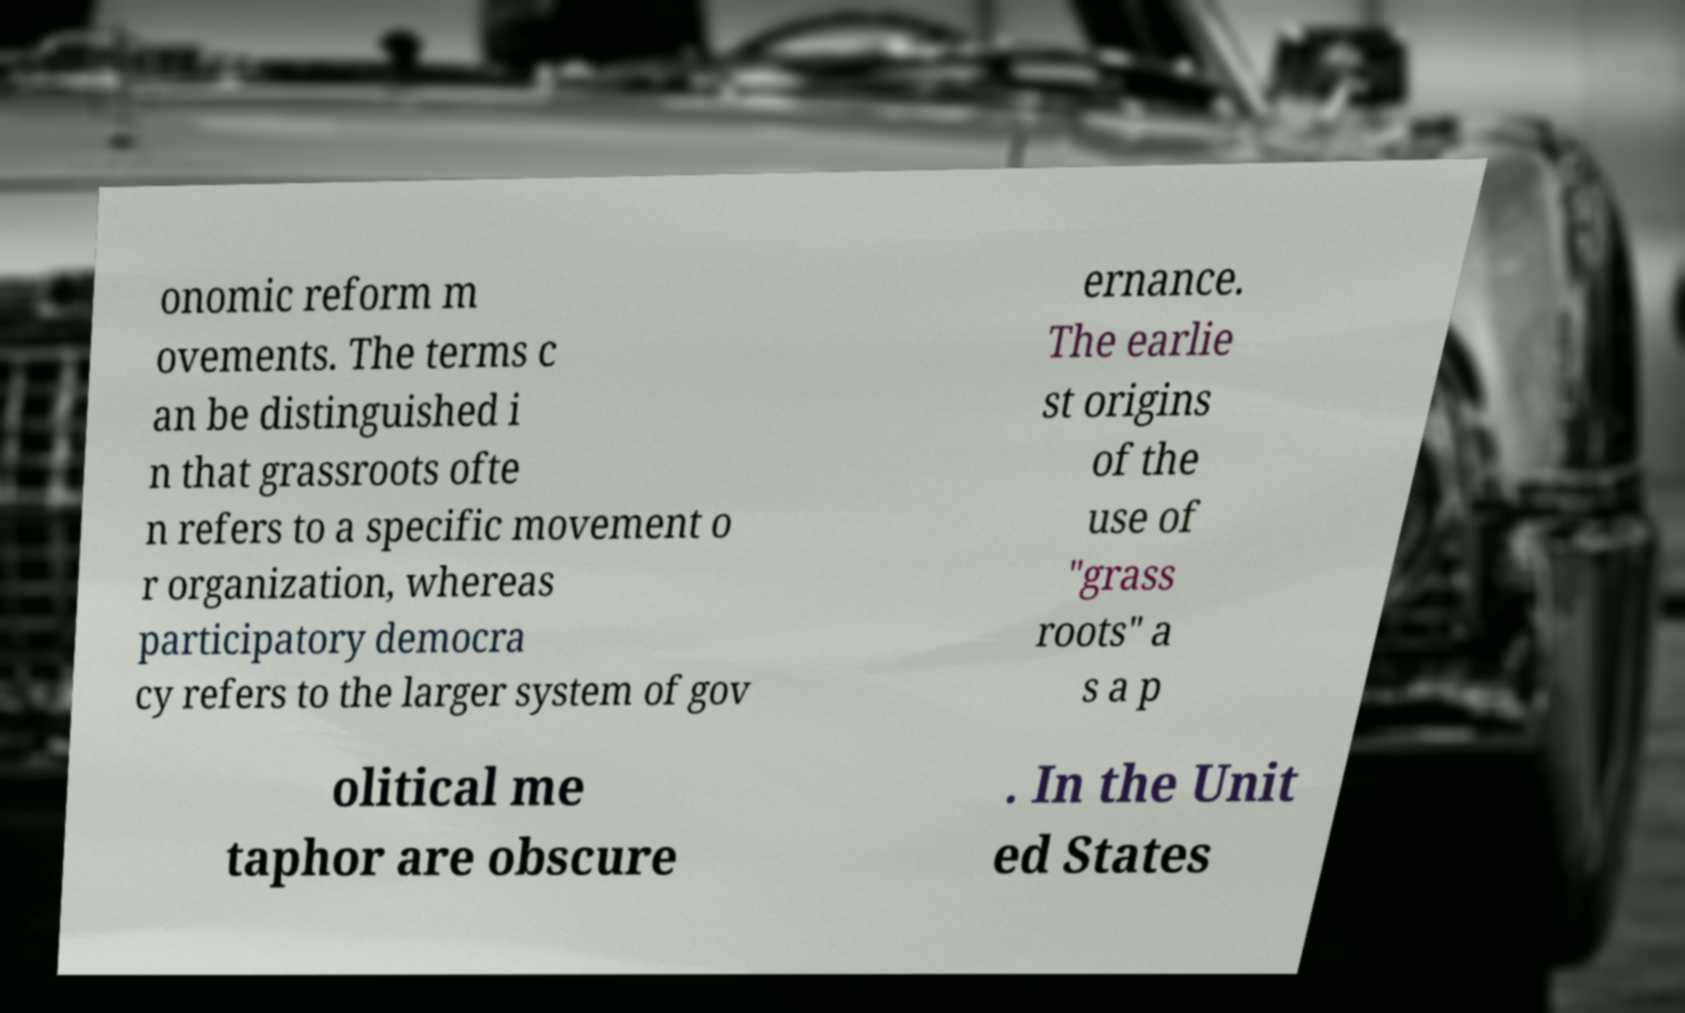Could you assist in decoding the text presented in this image and type it out clearly? onomic reform m ovements. The terms c an be distinguished i n that grassroots ofte n refers to a specific movement o r organization, whereas participatory democra cy refers to the larger system of gov ernance. The earlie st origins of the use of "grass roots" a s a p olitical me taphor are obscure . In the Unit ed States 